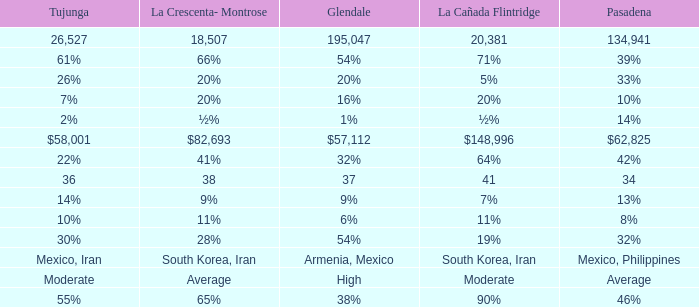When pasadena's figure is 34, what figure does la canada flintridge have? 41.0. 